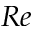Convert formula to latex. <formula><loc_0><loc_0><loc_500><loc_500>R e</formula> 